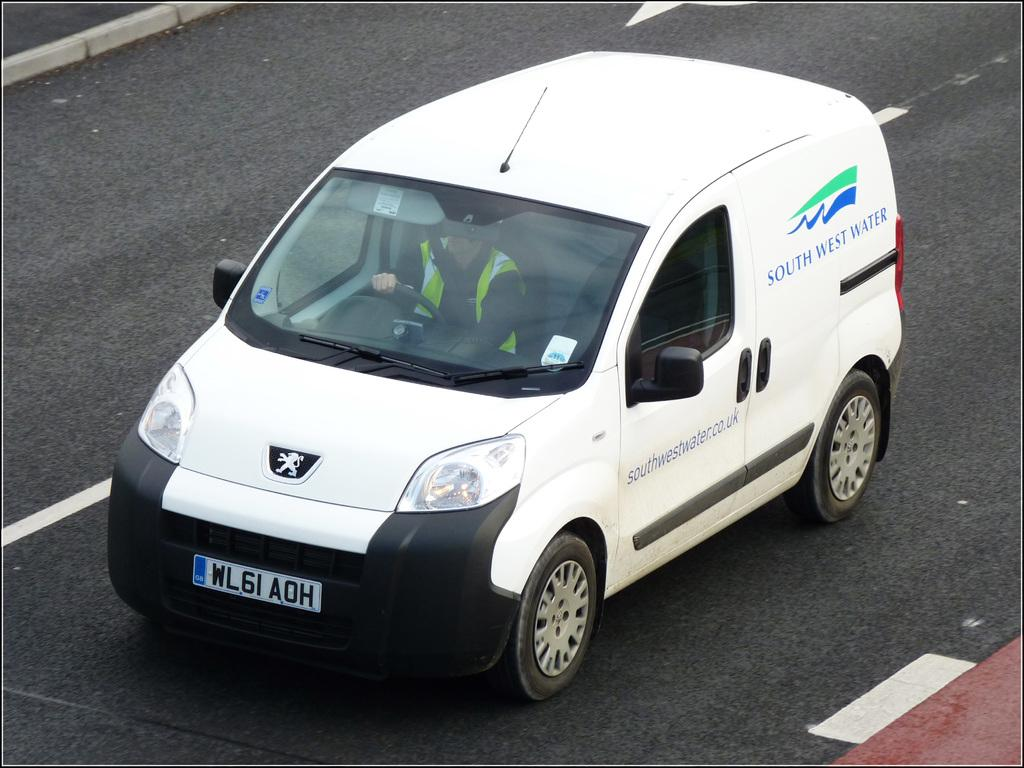<image>
Render a clear and concise summary of the photo. White van with the license plate WL6IAOH on it. 